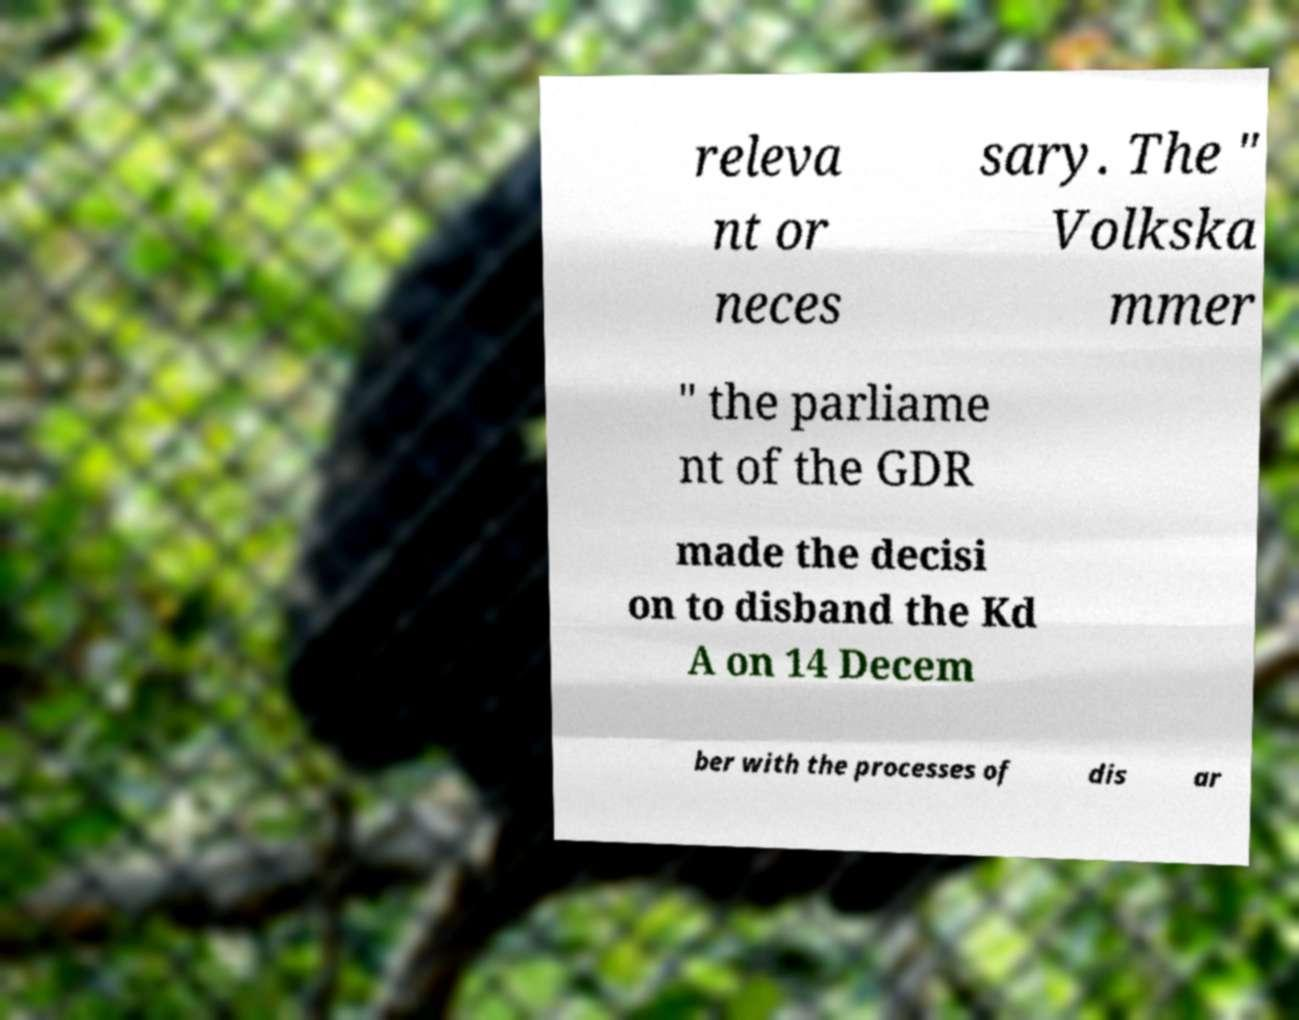Could you assist in decoding the text presented in this image and type it out clearly? releva nt or neces sary. The " Volkska mmer " the parliame nt of the GDR made the decisi on to disband the Kd A on 14 Decem ber with the processes of dis ar 